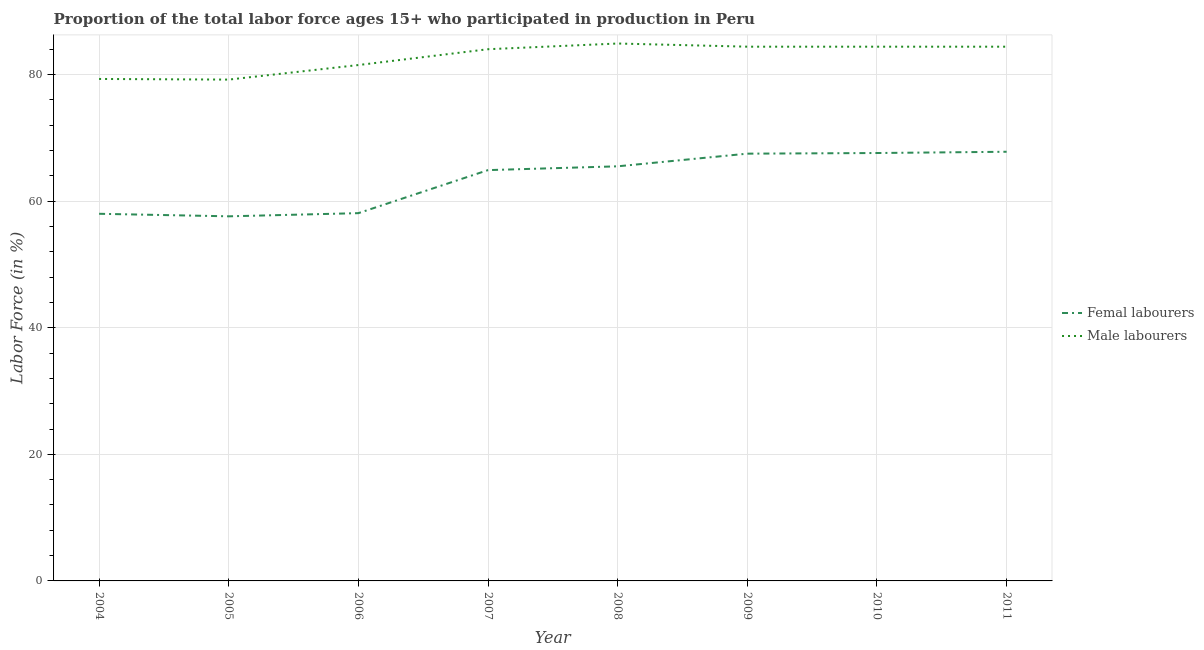How many different coloured lines are there?
Give a very brief answer. 2. Is the number of lines equal to the number of legend labels?
Make the answer very short. Yes. Across all years, what is the maximum percentage of female labor force?
Ensure brevity in your answer.  67.8. Across all years, what is the minimum percentage of male labour force?
Provide a succinct answer. 79.2. In which year was the percentage of male labour force maximum?
Make the answer very short. 2008. What is the total percentage of male labour force in the graph?
Keep it short and to the point. 662.1. What is the difference between the percentage of male labour force in 2004 and that in 2008?
Offer a terse response. -5.6. What is the difference between the percentage of female labor force in 2009 and the percentage of male labour force in 2010?
Provide a succinct answer. -16.9. What is the average percentage of female labor force per year?
Provide a short and direct response. 63.37. In the year 2008, what is the difference between the percentage of male labour force and percentage of female labor force?
Your answer should be compact. 19.4. In how many years, is the percentage of male labour force greater than 12 %?
Provide a succinct answer. 8. What is the ratio of the percentage of female labor force in 2009 to that in 2010?
Ensure brevity in your answer.  1. Is the percentage of female labor force in 2008 less than that in 2010?
Give a very brief answer. Yes. What is the difference between the highest and the second highest percentage of female labor force?
Offer a terse response. 0.2. What is the difference between the highest and the lowest percentage of female labor force?
Make the answer very short. 10.2. In how many years, is the percentage of female labor force greater than the average percentage of female labor force taken over all years?
Ensure brevity in your answer.  5. Does the percentage of male labour force monotonically increase over the years?
Your answer should be compact. No. Is the percentage of male labour force strictly less than the percentage of female labor force over the years?
Ensure brevity in your answer.  No. How many years are there in the graph?
Provide a short and direct response. 8. What is the difference between two consecutive major ticks on the Y-axis?
Offer a very short reply. 20. Are the values on the major ticks of Y-axis written in scientific E-notation?
Offer a terse response. No. Does the graph contain any zero values?
Provide a short and direct response. No. Where does the legend appear in the graph?
Give a very brief answer. Center right. How many legend labels are there?
Your answer should be very brief. 2. What is the title of the graph?
Make the answer very short. Proportion of the total labor force ages 15+ who participated in production in Peru. What is the label or title of the X-axis?
Offer a terse response. Year. What is the label or title of the Y-axis?
Make the answer very short. Labor Force (in %). What is the Labor Force (in %) in Femal labourers in 2004?
Give a very brief answer. 58. What is the Labor Force (in %) of Male labourers in 2004?
Ensure brevity in your answer.  79.3. What is the Labor Force (in %) of Femal labourers in 2005?
Provide a short and direct response. 57.6. What is the Labor Force (in %) of Male labourers in 2005?
Offer a very short reply. 79.2. What is the Labor Force (in %) of Femal labourers in 2006?
Make the answer very short. 58.1. What is the Labor Force (in %) in Male labourers in 2006?
Offer a very short reply. 81.5. What is the Labor Force (in %) in Femal labourers in 2007?
Keep it short and to the point. 64.9. What is the Labor Force (in %) in Male labourers in 2007?
Your answer should be very brief. 84. What is the Labor Force (in %) in Femal labourers in 2008?
Offer a terse response. 65.5. What is the Labor Force (in %) in Male labourers in 2008?
Provide a succinct answer. 84.9. What is the Labor Force (in %) in Femal labourers in 2009?
Give a very brief answer. 67.5. What is the Labor Force (in %) of Male labourers in 2009?
Provide a succinct answer. 84.4. What is the Labor Force (in %) of Femal labourers in 2010?
Your response must be concise. 67.6. What is the Labor Force (in %) of Male labourers in 2010?
Ensure brevity in your answer.  84.4. What is the Labor Force (in %) in Femal labourers in 2011?
Your response must be concise. 67.8. What is the Labor Force (in %) of Male labourers in 2011?
Make the answer very short. 84.4. Across all years, what is the maximum Labor Force (in %) in Femal labourers?
Make the answer very short. 67.8. Across all years, what is the maximum Labor Force (in %) of Male labourers?
Your answer should be very brief. 84.9. Across all years, what is the minimum Labor Force (in %) of Femal labourers?
Your response must be concise. 57.6. Across all years, what is the minimum Labor Force (in %) of Male labourers?
Keep it short and to the point. 79.2. What is the total Labor Force (in %) of Femal labourers in the graph?
Offer a very short reply. 507. What is the total Labor Force (in %) in Male labourers in the graph?
Your answer should be compact. 662.1. What is the difference between the Labor Force (in %) of Femal labourers in 2004 and that in 2005?
Your answer should be very brief. 0.4. What is the difference between the Labor Force (in %) in Male labourers in 2004 and that in 2006?
Ensure brevity in your answer.  -2.2. What is the difference between the Labor Force (in %) of Male labourers in 2004 and that in 2009?
Your response must be concise. -5.1. What is the difference between the Labor Force (in %) in Male labourers in 2004 and that in 2010?
Your response must be concise. -5.1. What is the difference between the Labor Force (in %) of Femal labourers in 2005 and that in 2007?
Keep it short and to the point. -7.3. What is the difference between the Labor Force (in %) in Male labourers in 2005 and that in 2007?
Ensure brevity in your answer.  -4.8. What is the difference between the Labor Force (in %) of Male labourers in 2005 and that in 2008?
Give a very brief answer. -5.7. What is the difference between the Labor Force (in %) of Femal labourers in 2005 and that in 2010?
Provide a succinct answer. -10. What is the difference between the Labor Force (in %) in Male labourers in 2005 and that in 2010?
Your answer should be compact. -5.2. What is the difference between the Labor Force (in %) of Femal labourers in 2005 and that in 2011?
Your response must be concise. -10.2. What is the difference between the Labor Force (in %) in Male labourers in 2005 and that in 2011?
Make the answer very short. -5.2. What is the difference between the Labor Force (in %) of Femal labourers in 2006 and that in 2007?
Your answer should be compact. -6.8. What is the difference between the Labor Force (in %) in Femal labourers in 2006 and that in 2008?
Give a very brief answer. -7.4. What is the difference between the Labor Force (in %) in Femal labourers in 2006 and that in 2009?
Provide a succinct answer. -9.4. What is the difference between the Labor Force (in %) of Femal labourers in 2006 and that in 2010?
Your answer should be compact. -9.5. What is the difference between the Labor Force (in %) in Male labourers in 2006 and that in 2010?
Your response must be concise. -2.9. What is the difference between the Labor Force (in %) in Femal labourers in 2006 and that in 2011?
Provide a short and direct response. -9.7. What is the difference between the Labor Force (in %) of Male labourers in 2006 and that in 2011?
Give a very brief answer. -2.9. What is the difference between the Labor Force (in %) of Femal labourers in 2007 and that in 2008?
Provide a succinct answer. -0.6. What is the difference between the Labor Force (in %) of Male labourers in 2007 and that in 2008?
Give a very brief answer. -0.9. What is the difference between the Labor Force (in %) of Femal labourers in 2007 and that in 2009?
Offer a very short reply. -2.6. What is the difference between the Labor Force (in %) in Male labourers in 2007 and that in 2009?
Keep it short and to the point. -0.4. What is the difference between the Labor Force (in %) of Femal labourers in 2007 and that in 2010?
Your answer should be very brief. -2.7. What is the difference between the Labor Force (in %) of Femal labourers in 2007 and that in 2011?
Offer a very short reply. -2.9. What is the difference between the Labor Force (in %) of Male labourers in 2007 and that in 2011?
Offer a very short reply. -0.4. What is the difference between the Labor Force (in %) of Male labourers in 2008 and that in 2009?
Your response must be concise. 0.5. What is the difference between the Labor Force (in %) of Femal labourers in 2008 and that in 2011?
Offer a very short reply. -2.3. What is the difference between the Labor Force (in %) of Femal labourers in 2009 and that in 2010?
Offer a very short reply. -0.1. What is the difference between the Labor Force (in %) of Femal labourers in 2009 and that in 2011?
Your answer should be compact. -0.3. What is the difference between the Labor Force (in %) of Femal labourers in 2010 and that in 2011?
Make the answer very short. -0.2. What is the difference between the Labor Force (in %) of Femal labourers in 2004 and the Labor Force (in %) of Male labourers in 2005?
Make the answer very short. -21.2. What is the difference between the Labor Force (in %) of Femal labourers in 2004 and the Labor Force (in %) of Male labourers in 2006?
Your answer should be compact. -23.5. What is the difference between the Labor Force (in %) of Femal labourers in 2004 and the Labor Force (in %) of Male labourers in 2007?
Provide a short and direct response. -26. What is the difference between the Labor Force (in %) of Femal labourers in 2004 and the Labor Force (in %) of Male labourers in 2008?
Your answer should be compact. -26.9. What is the difference between the Labor Force (in %) in Femal labourers in 2004 and the Labor Force (in %) in Male labourers in 2009?
Give a very brief answer. -26.4. What is the difference between the Labor Force (in %) in Femal labourers in 2004 and the Labor Force (in %) in Male labourers in 2010?
Give a very brief answer. -26.4. What is the difference between the Labor Force (in %) of Femal labourers in 2004 and the Labor Force (in %) of Male labourers in 2011?
Offer a very short reply. -26.4. What is the difference between the Labor Force (in %) in Femal labourers in 2005 and the Labor Force (in %) in Male labourers in 2006?
Provide a succinct answer. -23.9. What is the difference between the Labor Force (in %) of Femal labourers in 2005 and the Labor Force (in %) of Male labourers in 2007?
Your answer should be very brief. -26.4. What is the difference between the Labor Force (in %) in Femal labourers in 2005 and the Labor Force (in %) in Male labourers in 2008?
Ensure brevity in your answer.  -27.3. What is the difference between the Labor Force (in %) in Femal labourers in 2005 and the Labor Force (in %) in Male labourers in 2009?
Provide a succinct answer. -26.8. What is the difference between the Labor Force (in %) in Femal labourers in 2005 and the Labor Force (in %) in Male labourers in 2010?
Your answer should be compact. -26.8. What is the difference between the Labor Force (in %) of Femal labourers in 2005 and the Labor Force (in %) of Male labourers in 2011?
Provide a short and direct response. -26.8. What is the difference between the Labor Force (in %) of Femal labourers in 2006 and the Labor Force (in %) of Male labourers in 2007?
Offer a very short reply. -25.9. What is the difference between the Labor Force (in %) in Femal labourers in 2006 and the Labor Force (in %) in Male labourers in 2008?
Give a very brief answer. -26.8. What is the difference between the Labor Force (in %) of Femal labourers in 2006 and the Labor Force (in %) of Male labourers in 2009?
Give a very brief answer. -26.3. What is the difference between the Labor Force (in %) in Femal labourers in 2006 and the Labor Force (in %) in Male labourers in 2010?
Offer a very short reply. -26.3. What is the difference between the Labor Force (in %) of Femal labourers in 2006 and the Labor Force (in %) of Male labourers in 2011?
Provide a succinct answer. -26.3. What is the difference between the Labor Force (in %) in Femal labourers in 2007 and the Labor Force (in %) in Male labourers in 2008?
Provide a short and direct response. -20. What is the difference between the Labor Force (in %) in Femal labourers in 2007 and the Labor Force (in %) in Male labourers in 2009?
Provide a succinct answer. -19.5. What is the difference between the Labor Force (in %) of Femal labourers in 2007 and the Labor Force (in %) of Male labourers in 2010?
Offer a terse response. -19.5. What is the difference between the Labor Force (in %) in Femal labourers in 2007 and the Labor Force (in %) in Male labourers in 2011?
Your response must be concise. -19.5. What is the difference between the Labor Force (in %) of Femal labourers in 2008 and the Labor Force (in %) of Male labourers in 2009?
Provide a succinct answer. -18.9. What is the difference between the Labor Force (in %) of Femal labourers in 2008 and the Labor Force (in %) of Male labourers in 2010?
Your answer should be very brief. -18.9. What is the difference between the Labor Force (in %) of Femal labourers in 2008 and the Labor Force (in %) of Male labourers in 2011?
Offer a terse response. -18.9. What is the difference between the Labor Force (in %) of Femal labourers in 2009 and the Labor Force (in %) of Male labourers in 2010?
Offer a very short reply. -16.9. What is the difference between the Labor Force (in %) in Femal labourers in 2009 and the Labor Force (in %) in Male labourers in 2011?
Make the answer very short. -16.9. What is the difference between the Labor Force (in %) of Femal labourers in 2010 and the Labor Force (in %) of Male labourers in 2011?
Provide a succinct answer. -16.8. What is the average Labor Force (in %) of Femal labourers per year?
Give a very brief answer. 63.38. What is the average Labor Force (in %) in Male labourers per year?
Offer a very short reply. 82.76. In the year 2004, what is the difference between the Labor Force (in %) in Femal labourers and Labor Force (in %) in Male labourers?
Make the answer very short. -21.3. In the year 2005, what is the difference between the Labor Force (in %) of Femal labourers and Labor Force (in %) of Male labourers?
Give a very brief answer. -21.6. In the year 2006, what is the difference between the Labor Force (in %) in Femal labourers and Labor Force (in %) in Male labourers?
Your answer should be compact. -23.4. In the year 2007, what is the difference between the Labor Force (in %) in Femal labourers and Labor Force (in %) in Male labourers?
Provide a succinct answer. -19.1. In the year 2008, what is the difference between the Labor Force (in %) in Femal labourers and Labor Force (in %) in Male labourers?
Your answer should be compact. -19.4. In the year 2009, what is the difference between the Labor Force (in %) in Femal labourers and Labor Force (in %) in Male labourers?
Your answer should be compact. -16.9. In the year 2010, what is the difference between the Labor Force (in %) of Femal labourers and Labor Force (in %) of Male labourers?
Your answer should be very brief. -16.8. In the year 2011, what is the difference between the Labor Force (in %) of Femal labourers and Labor Force (in %) of Male labourers?
Keep it short and to the point. -16.6. What is the ratio of the Labor Force (in %) in Femal labourers in 2004 to that in 2005?
Give a very brief answer. 1.01. What is the ratio of the Labor Force (in %) of Male labourers in 2004 to that in 2005?
Offer a terse response. 1. What is the ratio of the Labor Force (in %) in Femal labourers in 2004 to that in 2006?
Provide a succinct answer. 1. What is the ratio of the Labor Force (in %) in Male labourers in 2004 to that in 2006?
Make the answer very short. 0.97. What is the ratio of the Labor Force (in %) in Femal labourers in 2004 to that in 2007?
Your response must be concise. 0.89. What is the ratio of the Labor Force (in %) in Male labourers in 2004 to that in 2007?
Your answer should be compact. 0.94. What is the ratio of the Labor Force (in %) in Femal labourers in 2004 to that in 2008?
Offer a very short reply. 0.89. What is the ratio of the Labor Force (in %) of Male labourers in 2004 to that in 2008?
Your answer should be very brief. 0.93. What is the ratio of the Labor Force (in %) of Femal labourers in 2004 to that in 2009?
Provide a succinct answer. 0.86. What is the ratio of the Labor Force (in %) in Male labourers in 2004 to that in 2009?
Your answer should be very brief. 0.94. What is the ratio of the Labor Force (in %) in Femal labourers in 2004 to that in 2010?
Ensure brevity in your answer.  0.86. What is the ratio of the Labor Force (in %) in Male labourers in 2004 to that in 2010?
Keep it short and to the point. 0.94. What is the ratio of the Labor Force (in %) of Femal labourers in 2004 to that in 2011?
Give a very brief answer. 0.86. What is the ratio of the Labor Force (in %) of Male labourers in 2004 to that in 2011?
Offer a very short reply. 0.94. What is the ratio of the Labor Force (in %) of Femal labourers in 2005 to that in 2006?
Offer a terse response. 0.99. What is the ratio of the Labor Force (in %) in Male labourers in 2005 to that in 2006?
Provide a short and direct response. 0.97. What is the ratio of the Labor Force (in %) of Femal labourers in 2005 to that in 2007?
Offer a very short reply. 0.89. What is the ratio of the Labor Force (in %) in Male labourers in 2005 to that in 2007?
Offer a terse response. 0.94. What is the ratio of the Labor Force (in %) in Femal labourers in 2005 to that in 2008?
Make the answer very short. 0.88. What is the ratio of the Labor Force (in %) in Male labourers in 2005 to that in 2008?
Make the answer very short. 0.93. What is the ratio of the Labor Force (in %) in Femal labourers in 2005 to that in 2009?
Keep it short and to the point. 0.85. What is the ratio of the Labor Force (in %) in Male labourers in 2005 to that in 2009?
Your answer should be compact. 0.94. What is the ratio of the Labor Force (in %) in Femal labourers in 2005 to that in 2010?
Provide a short and direct response. 0.85. What is the ratio of the Labor Force (in %) of Male labourers in 2005 to that in 2010?
Give a very brief answer. 0.94. What is the ratio of the Labor Force (in %) of Femal labourers in 2005 to that in 2011?
Give a very brief answer. 0.85. What is the ratio of the Labor Force (in %) in Male labourers in 2005 to that in 2011?
Offer a terse response. 0.94. What is the ratio of the Labor Force (in %) of Femal labourers in 2006 to that in 2007?
Make the answer very short. 0.9. What is the ratio of the Labor Force (in %) in Male labourers in 2006 to that in 2007?
Provide a short and direct response. 0.97. What is the ratio of the Labor Force (in %) of Femal labourers in 2006 to that in 2008?
Give a very brief answer. 0.89. What is the ratio of the Labor Force (in %) in Femal labourers in 2006 to that in 2009?
Your answer should be compact. 0.86. What is the ratio of the Labor Force (in %) of Male labourers in 2006 to that in 2009?
Your answer should be compact. 0.97. What is the ratio of the Labor Force (in %) of Femal labourers in 2006 to that in 2010?
Provide a succinct answer. 0.86. What is the ratio of the Labor Force (in %) in Male labourers in 2006 to that in 2010?
Your answer should be very brief. 0.97. What is the ratio of the Labor Force (in %) of Femal labourers in 2006 to that in 2011?
Provide a succinct answer. 0.86. What is the ratio of the Labor Force (in %) in Male labourers in 2006 to that in 2011?
Your answer should be compact. 0.97. What is the ratio of the Labor Force (in %) in Femal labourers in 2007 to that in 2008?
Your answer should be compact. 0.99. What is the ratio of the Labor Force (in %) in Femal labourers in 2007 to that in 2009?
Provide a succinct answer. 0.96. What is the ratio of the Labor Force (in %) in Male labourers in 2007 to that in 2009?
Give a very brief answer. 1. What is the ratio of the Labor Force (in %) in Femal labourers in 2007 to that in 2010?
Provide a succinct answer. 0.96. What is the ratio of the Labor Force (in %) of Femal labourers in 2007 to that in 2011?
Provide a succinct answer. 0.96. What is the ratio of the Labor Force (in %) in Male labourers in 2007 to that in 2011?
Ensure brevity in your answer.  1. What is the ratio of the Labor Force (in %) in Femal labourers in 2008 to that in 2009?
Offer a terse response. 0.97. What is the ratio of the Labor Force (in %) of Male labourers in 2008 to that in 2009?
Keep it short and to the point. 1.01. What is the ratio of the Labor Force (in %) in Femal labourers in 2008 to that in 2010?
Ensure brevity in your answer.  0.97. What is the ratio of the Labor Force (in %) of Male labourers in 2008 to that in 2010?
Give a very brief answer. 1.01. What is the ratio of the Labor Force (in %) of Femal labourers in 2008 to that in 2011?
Provide a short and direct response. 0.97. What is the ratio of the Labor Force (in %) in Male labourers in 2008 to that in 2011?
Offer a very short reply. 1.01. What is the ratio of the Labor Force (in %) of Male labourers in 2009 to that in 2011?
Offer a terse response. 1. What is the ratio of the Labor Force (in %) of Femal labourers in 2010 to that in 2011?
Give a very brief answer. 1. What is the ratio of the Labor Force (in %) in Male labourers in 2010 to that in 2011?
Ensure brevity in your answer.  1. What is the difference between the highest and the second highest Labor Force (in %) in Femal labourers?
Offer a terse response. 0.2. What is the difference between the highest and the second highest Labor Force (in %) in Male labourers?
Offer a terse response. 0.5. What is the difference between the highest and the lowest Labor Force (in %) in Male labourers?
Your answer should be compact. 5.7. 